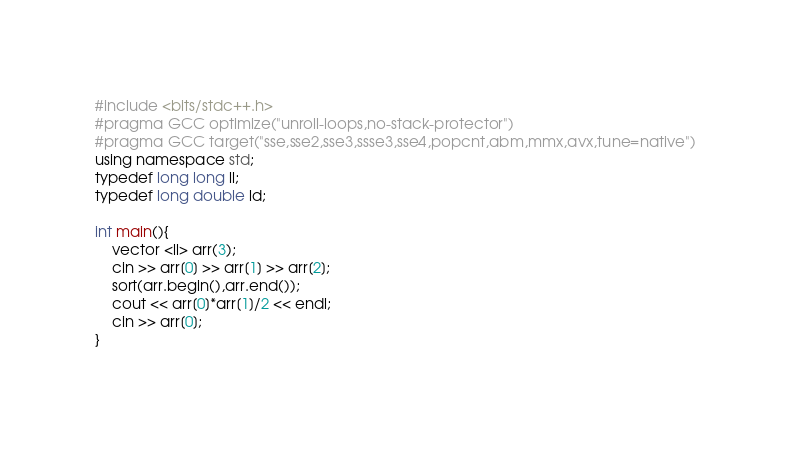Convert code to text. <code><loc_0><loc_0><loc_500><loc_500><_C++_>#include <bits/stdc++.h>
#pragma GCC optimize("unroll-loops,no-stack-protector")
#pragma GCC target("sse,sse2,sse3,ssse3,sse4,popcnt,abm,mmx,avx,tune=native")
using namespace std;
typedef long long ll;
typedef long double ld;

int main(){
	vector <ll> arr(3);
	cin >> arr[0] >> arr[1] >> arr[2];
	sort(arr.begin(),arr.end());
	cout << arr[0]*arr[1]/2 << endl;
	cin >> arr[0];
}
 </code> 